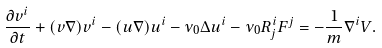Convert formula to latex. <formula><loc_0><loc_0><loc_500><loc_500>\frac { \partial v ^ { i } } { \partial t } + ( v \nabla ) v ^ { i } - ( u \nabla ) u ^ { i } - \nu _ { 0 } \Delta u ^ { i } - \nu _ { 0 } R _ { j } ^ { i } F ^ { j } = - \frac { 1 } { m } \nabla ^ { i } V .</formula> 